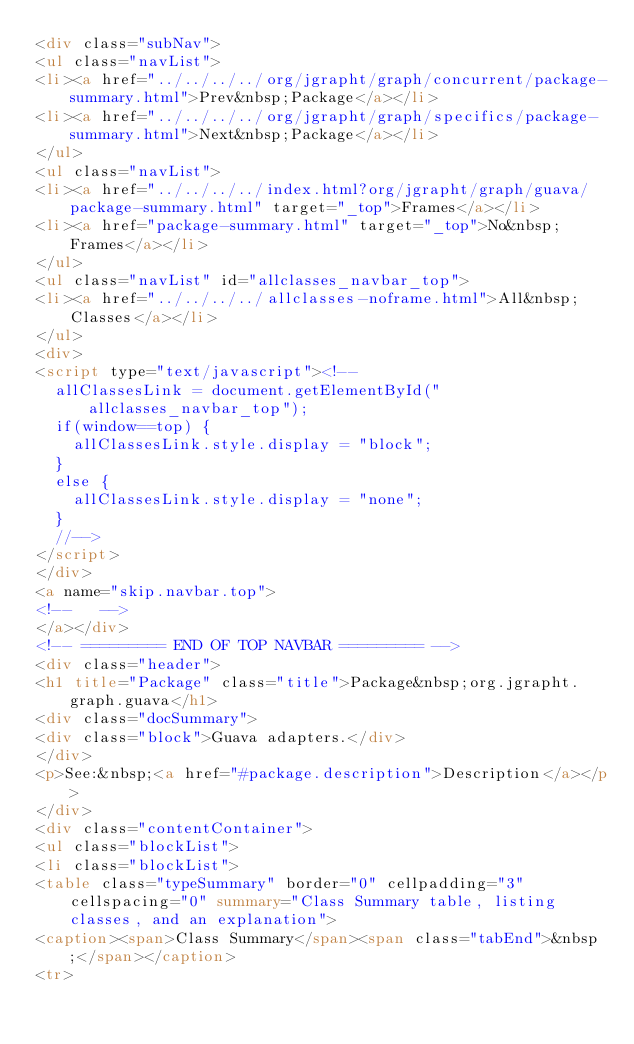<code> <loc_0><loc_0><loc_500><loc_500><_HTML_><div class="subNav">
<ul class="navList">
<li><a href="../../../../org/jgrapht/graph/concurrent/package-summary.html">Prev&nbsp;Package</a></li>
<li><a href="../../../../org/jgrapht/graph/specifics/package-summary.html">Next&nbsp;Package</a></li>
</ul>
<ul class="navList">
<li><a href="../../../../index.html?org/jgrapht/graph/guava/package-summary.html" target="_top">Frames</a></li>
<li><a href="package-summary.html" target="_top">No&nbsp;Frames</a></li>
</ul>
<ul class="navList" id="allclasses_navbar_top">
<li><a href="../../../../allclasses-noframe.html">All&nbsp;Classes</a></li>
</ul>
<div>
<script type="text/javascript"><!--
  allClassesLink = document.getElementById("allclasses_navbar_top");
  if(window==top) {
    allClassesLink.style.display = "block";
  }
  else {
    allClassesLink.style.display = "none";
  }
  //-->
</script>
</div>
<a name="skip.navbar.top">
<!--   -->
</a></div>
<!-- ========= END OF TOP NAVBAR ========= -->
<div class="header">
<h1 title="Package" class="title">Package&nbsp;org.jgrapht.graph.guava</h1>
<div class="docSummary">
<div class="block">Guava adapters.</div>
</div>
<p>See:&nbsp;<a href="#package.description">Description</a></p>
</div>
<div class="contentContainer">
<ul class="blockList">
<li class="blockList">
<table class="typeSummary" border="0" cellpadding="3" cellspacing="0" summary="Class Summary table, listing classes, and an explanation">
<caption><span>Class Summary</span><span class="tabEnd">&nbsp;</span></caption>
<tr></code> 